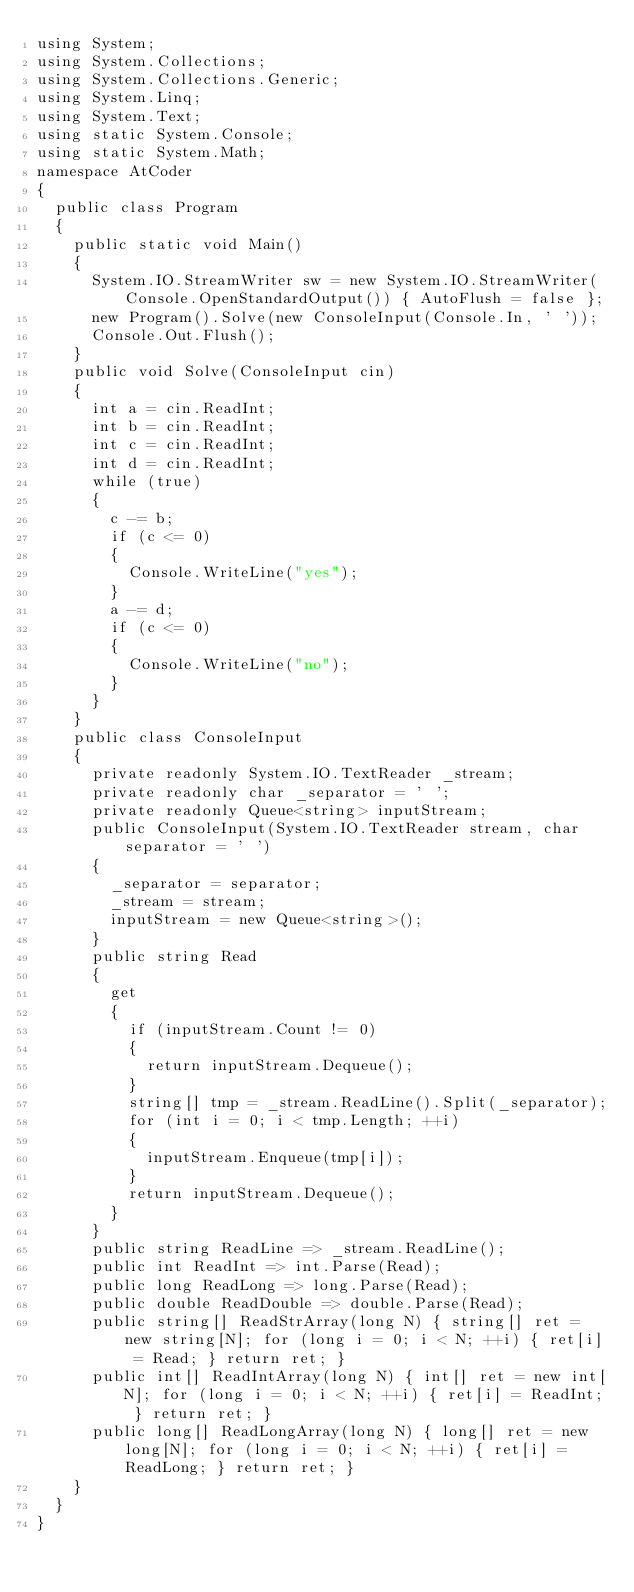Convert code to text. <code><loc_0><loc_0><loc_500><loc_500><_C#_>using System;
using System.Collections;
using System.Collections.Generic;
using System.Linq;
using System.Text;
using static System.Console;
using static System.Math;
namespace AtCoder
{
	public class Program
	{
		public static void Main()
		{
			System.IO.StreamWriter sw = new System.IO.StreamWriter(Console.OpenStandardOutput()) { AutoFlush = false };
			new Program().Solve(new ConsoleInput(Console.In, ' '));
			Console.Out.Flush();
		}
		public void Solve(ConsoleInput cin)
		{
			int a = cin.ReadInt;
			int b = cin.ReadInt;
			int c = cin.ReadInt;
			int d = cin.ReadInt;
			while (true)
			{
				c -= b;
				if (c <= 0)
				{
					Console.WriteLine("yes");
				}
				a -= d;
				if (c <= 0)
				{
					Console.WriteLine("no");
				}
			}
		}
		public class ConsoleInput
		{
			private readonly System.IO.TextReader _stream;
			private readonly char _separator = ' ';
			private readonly Queue<string> inputStream;
			public ConsoleInput(System.IO.TextReader stream, char separator = ' ')
			{
				_separator = separator;
				_stream = stream;
				inputStream = new Queue<string>();
			}
			public string Read
			{
				get
				{
					if (inputStream.Count != 0)
					{
						return inputStream.Dequeue();
					}
					string[] tmp = _stream.ReadLine().Split(_separator);
					for (int i = 0; i < tmp.Length; ++i)
					{
						inputStream.Enqueue(tmp[i]);
					}
					return inputStream.Dequeue();
				}
			}
			public string ReadLine => _stream.ReadLine();
			public int ReadInt => int.Parse(Read);
			public long ReadLong => long.Parse(Read);
			public double ReadDouble => double.Parse(Read);
			public string[] ReadStrArray(long N) { string[] ret = new string[N]; for (long i = 0; i < N; ++i) { ret[i] = Read; } return ret; }
			public int[] ReadIntArray(long N) { int[] ret = new int[N]; for (long i = 0; i < N; ++i) { ret[i] = ReadInt; } return ret; }
			public long[] ReadLongArray(long N) { long[] ret = new long[N]; for (long i = 0; i < N; ++i) { ret[i] = ReadLong; } return ret; }
		}
	}
}</code> 